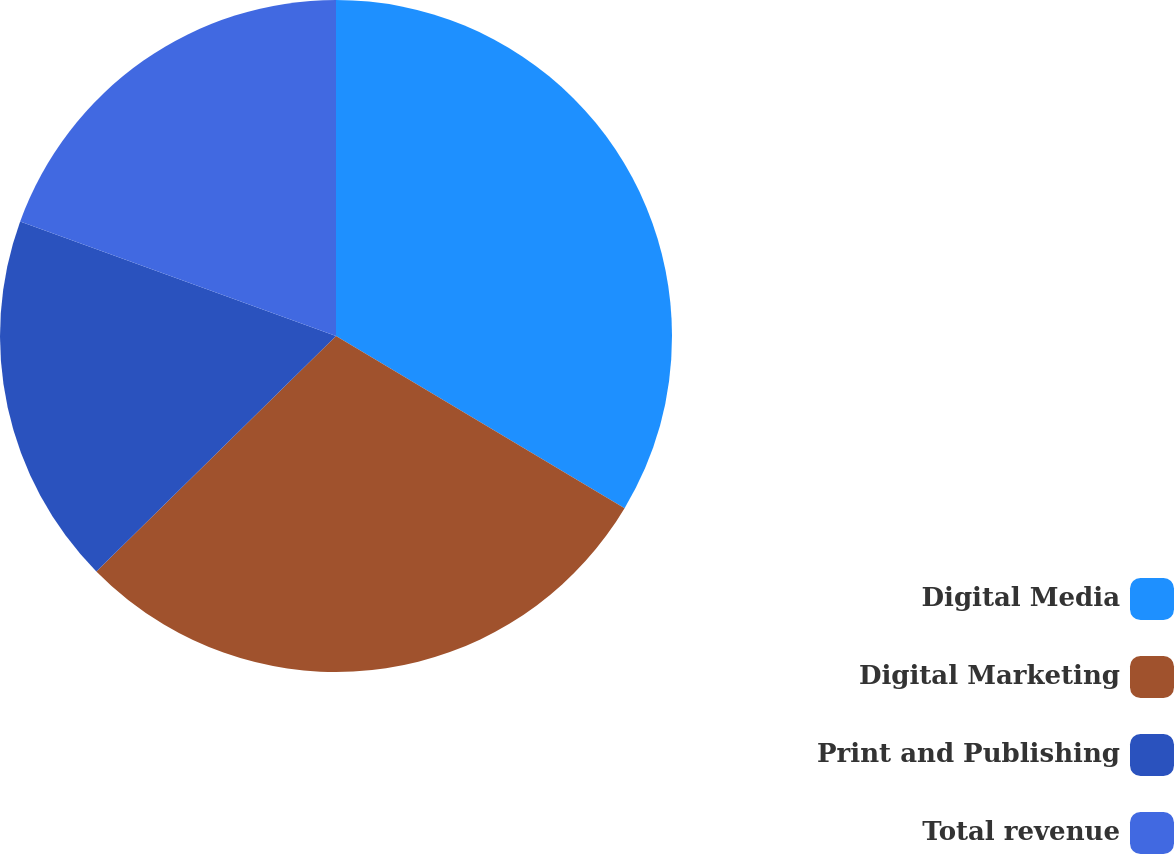<chart> <loc_0><loc_0><loc_500><loc_500><pie_chart><fcel>Digital Media<fcel>Digital Marketing<fcel>Print and Publishing<fcel>Total revenue<nl><fcel>33.56%<fcel>29.08%<fcel>17.9%<fcel>19.46%<nl></chart> 